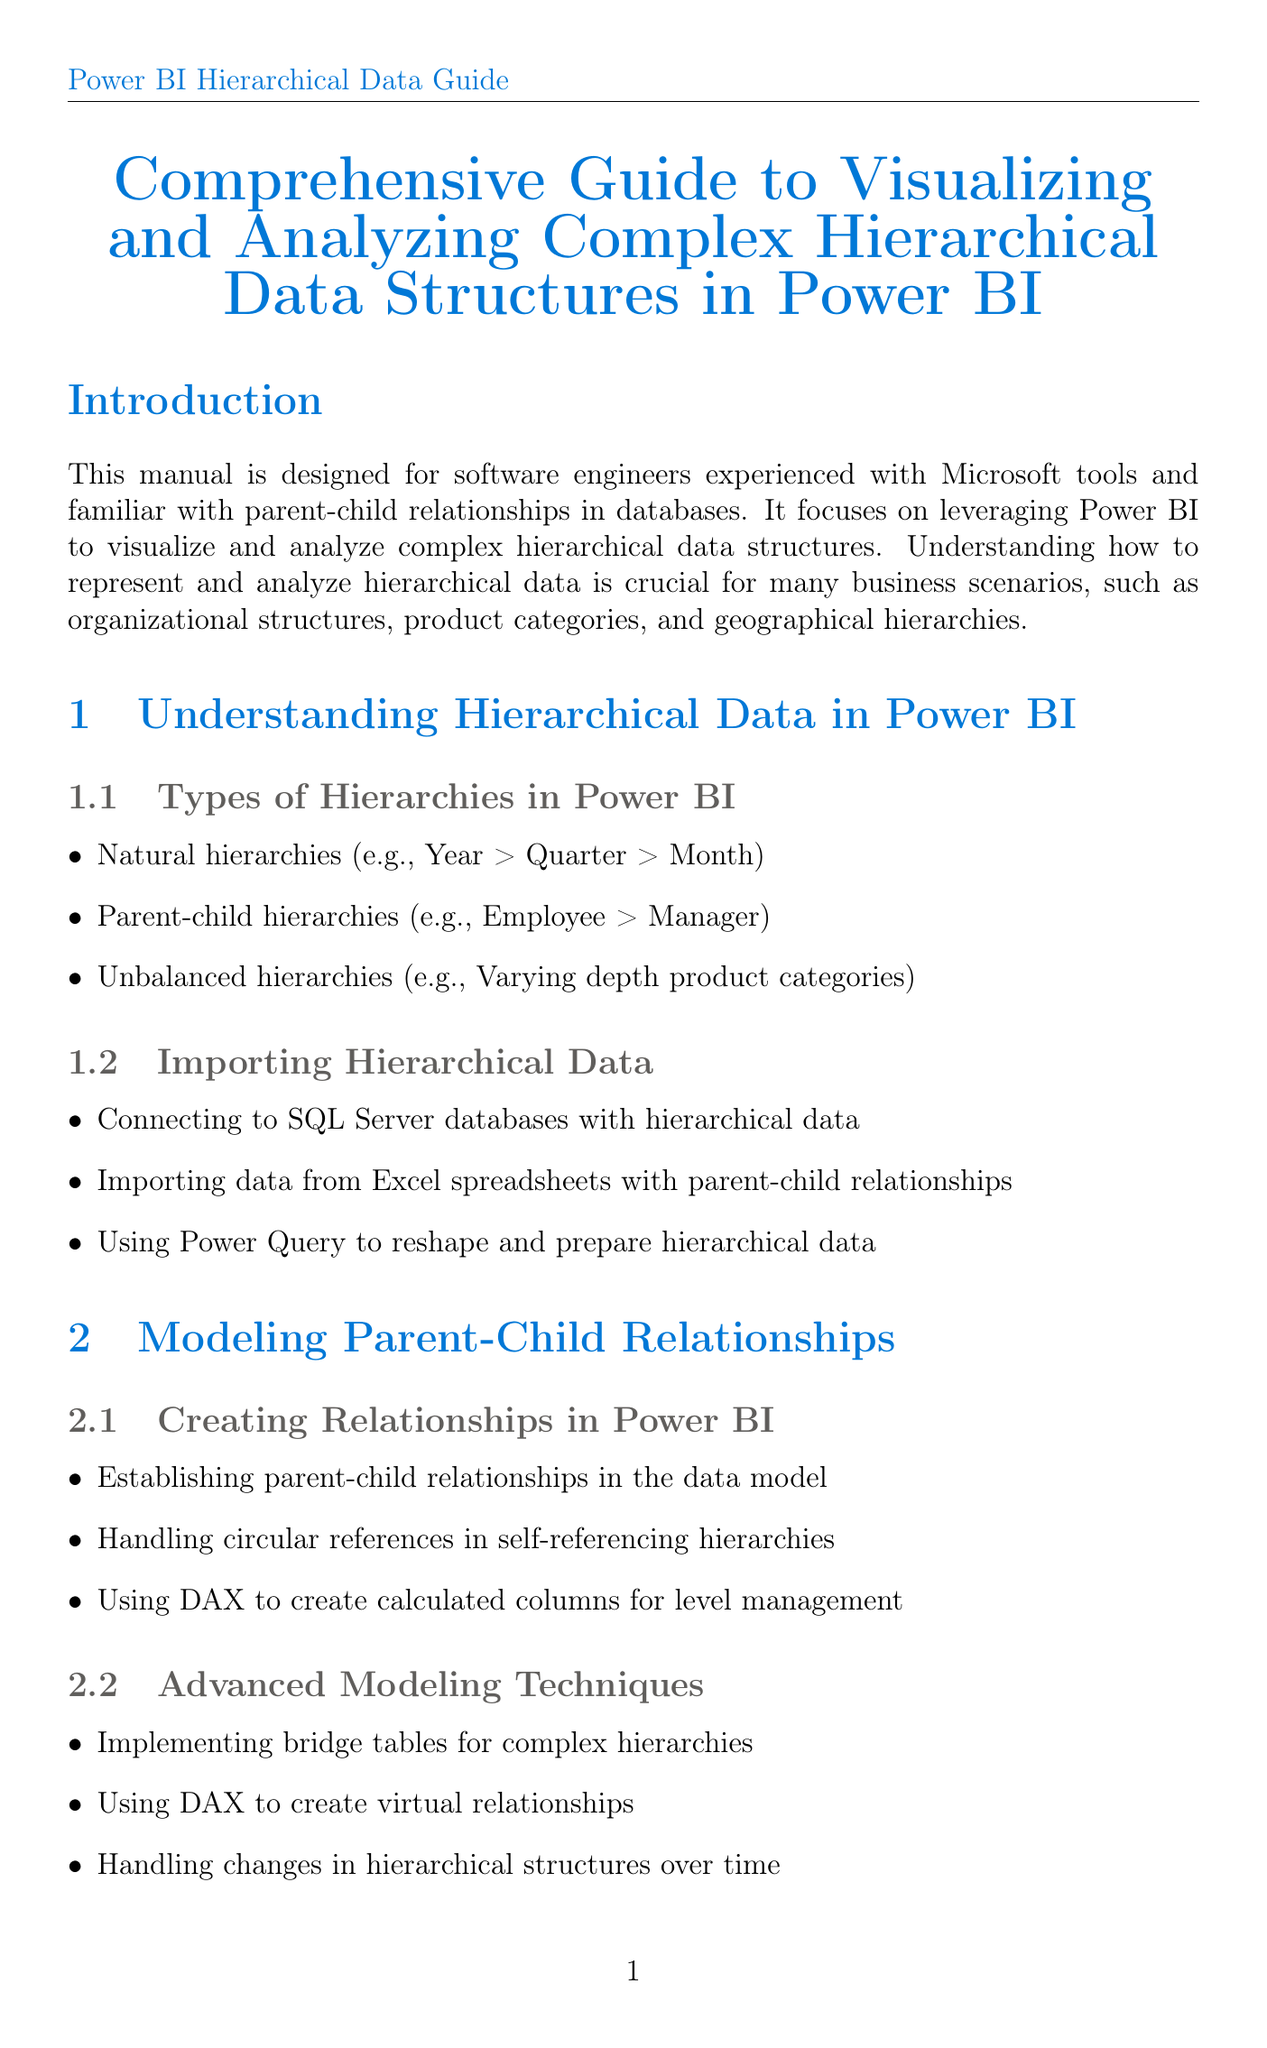What is the title of the manual? The title of the manual is presented at the very beginning of the document, summarizing its content on Power BI and hierarchical data structures.
Answer: Comprehensive Guide to Visualizing and Analyzing Complex Hierarchical Data Structures in Power BI What are the three types of hierarchies mentioned? The manual lists three specific types of hierarchies relevant to Power BI that can be found in the section on Types of Hierarchies.
Answer: Natural hierarchies, Parent-child hierarchies, Unbalanced hierarchies Which visual is mentioned for space-efficient hierarchy representation? The specific visual designed for representing hierarchical data efficiently is noted in the section on Hierarchy Visualizations.
Answer: Treemaps What DAX function is used for hierarchical ranking? The manual provides a DAX function as part of hierarchical calculations essential for ranking within the data model.
Answer: RANKX What is one of the advanced modeling techniques mentioned? The manual discusses various advanced techniques under the Modeling Parent-Child Relationships section, focusing on improving hierarchy management.
Answer: Implementing bridge tables for complex hierarchies What feature does the Decomposition Tree provide? The manual explains certain built-in features for drill-down functionalities that enhance user interaction with hierarchical data models in Power BI.
Answer: Dynamic drill-downs What is one next step suggested in the conclusion? The conclusion outlines future opportunities and steps for the reader to expand their knowledge and application of Power BI.
Answer: Explore advanced topics such as real-time hierarchical data analysis How many real-world case studies are presented in the manual? The document mentions specific case studies that exemplify the application of concepts discussed earlier, which are clearly outlined in the Real-World Case Studies section.
Answer: Two 